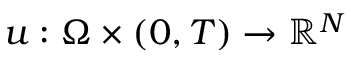<formula> <loc_0><loc_0><loc_500><loc_500>u \colon \Omega \times ( 0 , T ) \to \mathbb { R } ^ { N }</formula> 